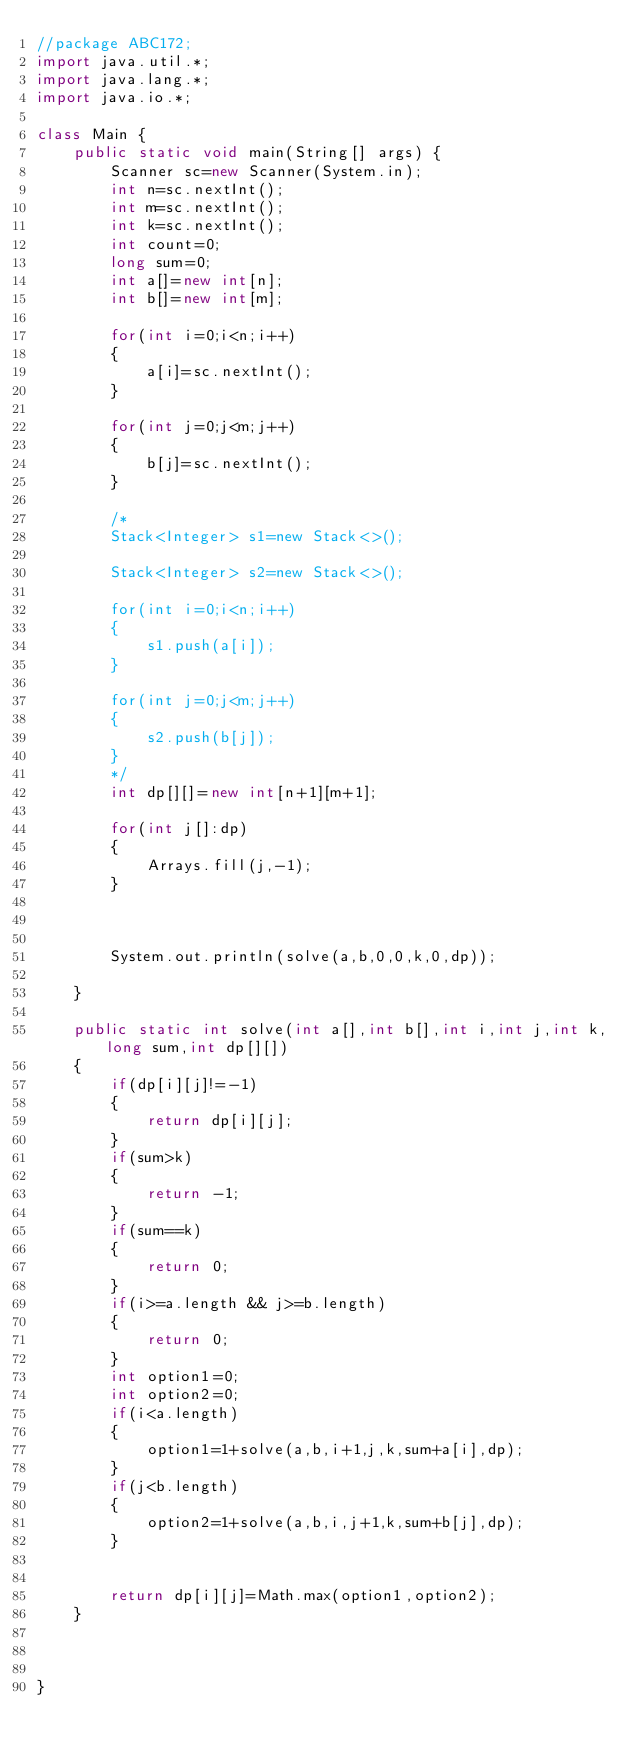<code> <loc_0><loc_0><loc_500><loc_500><_Java_>//package ABC172;
import java.util.*;
import java.lang.*;
import java.io.*;

class Main {
	public static void main(String[] args) {
		Scanner sc=new Scanner(System.in);
		int n=sc.nextInt();
		int m=sc.nextInt();
		int k=sc.nextInt();
		int count=0;
		long sum=0;
		int a[]=new int[n];
		int b[]=new int[m];
		
		for(int i=0;i<n;i++)
		{
			a[i]=sc.nextInt();
		}
		
		for(int j=0;j<m;j++)
		{
			b[j]=sc.nextInt();
		}
		
		/*
		Stack<Integer> s1=new Stack<>();
		
		Stack<Integer> s2=new Stack<>();
		
		for(int i=0;i<n;i++)
		{
			s1.push(a[i]);
		}
		
		for(int j=0;j<m;j++)
		{
			s2.push(b[j]);
		}
		*/
		int dp[][]=new int[n+1][m+1];
		
		for(int j[]:dp)
		{
			Arrays.fill(j,-1);
		}
		
		
		
		System.out.println(solve(a,b,0,0,k,0,dp));
		
	}
	
	public static int solve(int a[],int b[],int i,int j,int k,long sum,int dp[][])
	{
		if(dp[i][j]!=-1)
		{
			return dp[i][j];
		}
		if(sum>k)
		{
			return -1;
		}
		if(sum==k)
		{
			return 0;
		}
		if(i>=a.length && j>=b.length)
		{
			return 0;
		}
		int option1=0;
		int option2=0;
		if(i<a.length)
		{
			option1=1+solve(a,b,i+1,j,k,sum+a[i],dp);
		}
		if(j<b.length)
		{
			option2=1+solve(a,b,i,j+1,k,sum+b[j],dp);
		}
		
		
		return dp[i][j]=Math.max(option1,option2);
	}
	
	

}
</code> 